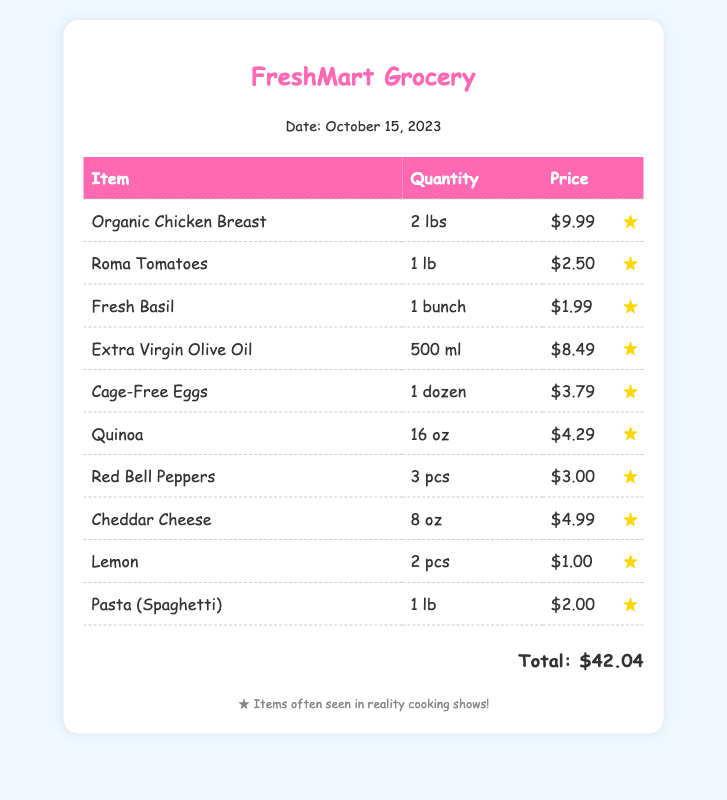What is the date of the shopping trip? The date of the shopping trip is mentioned in the document under store info.
Answer: October 15, 2023 What item is featured in the receipt that is commonly used for cooking? The item featured in the receipt that is frequently seen in cooking shows is highlighted in the document.
Answer: Organic Chicken Breast How much did the cage-free eggs cost? The cost of the cage-free eggs is listed next to the item in the table.
Answer: $3.79 What is the total amount spent on the grocery receipt? The total amount is provided at the bottom of the document.
Answer: $42.04 How many pounds of Roma tomatoes were purchased? The quantity of Roma tomatoes is mentioned in the table for that specific item.
Answer: 1 lb Which oil is included in the purchases? The type of oil included is listed in the featured section of the document.
Answer: Extra Virgin Olive Oil What type of cheese was bought? The type of cheese purchased can be found mentioned in the item list.
Answer: Cheddar Cheese How many lemons were included in the receipt? The number of lemons is specified in the quantity for that item.
Answer: 2 pcs What is the quantity of quinoa purchased? The quantity of quinoa can be seen next to the item in the table on the receipt.
Answer: 16 oz 